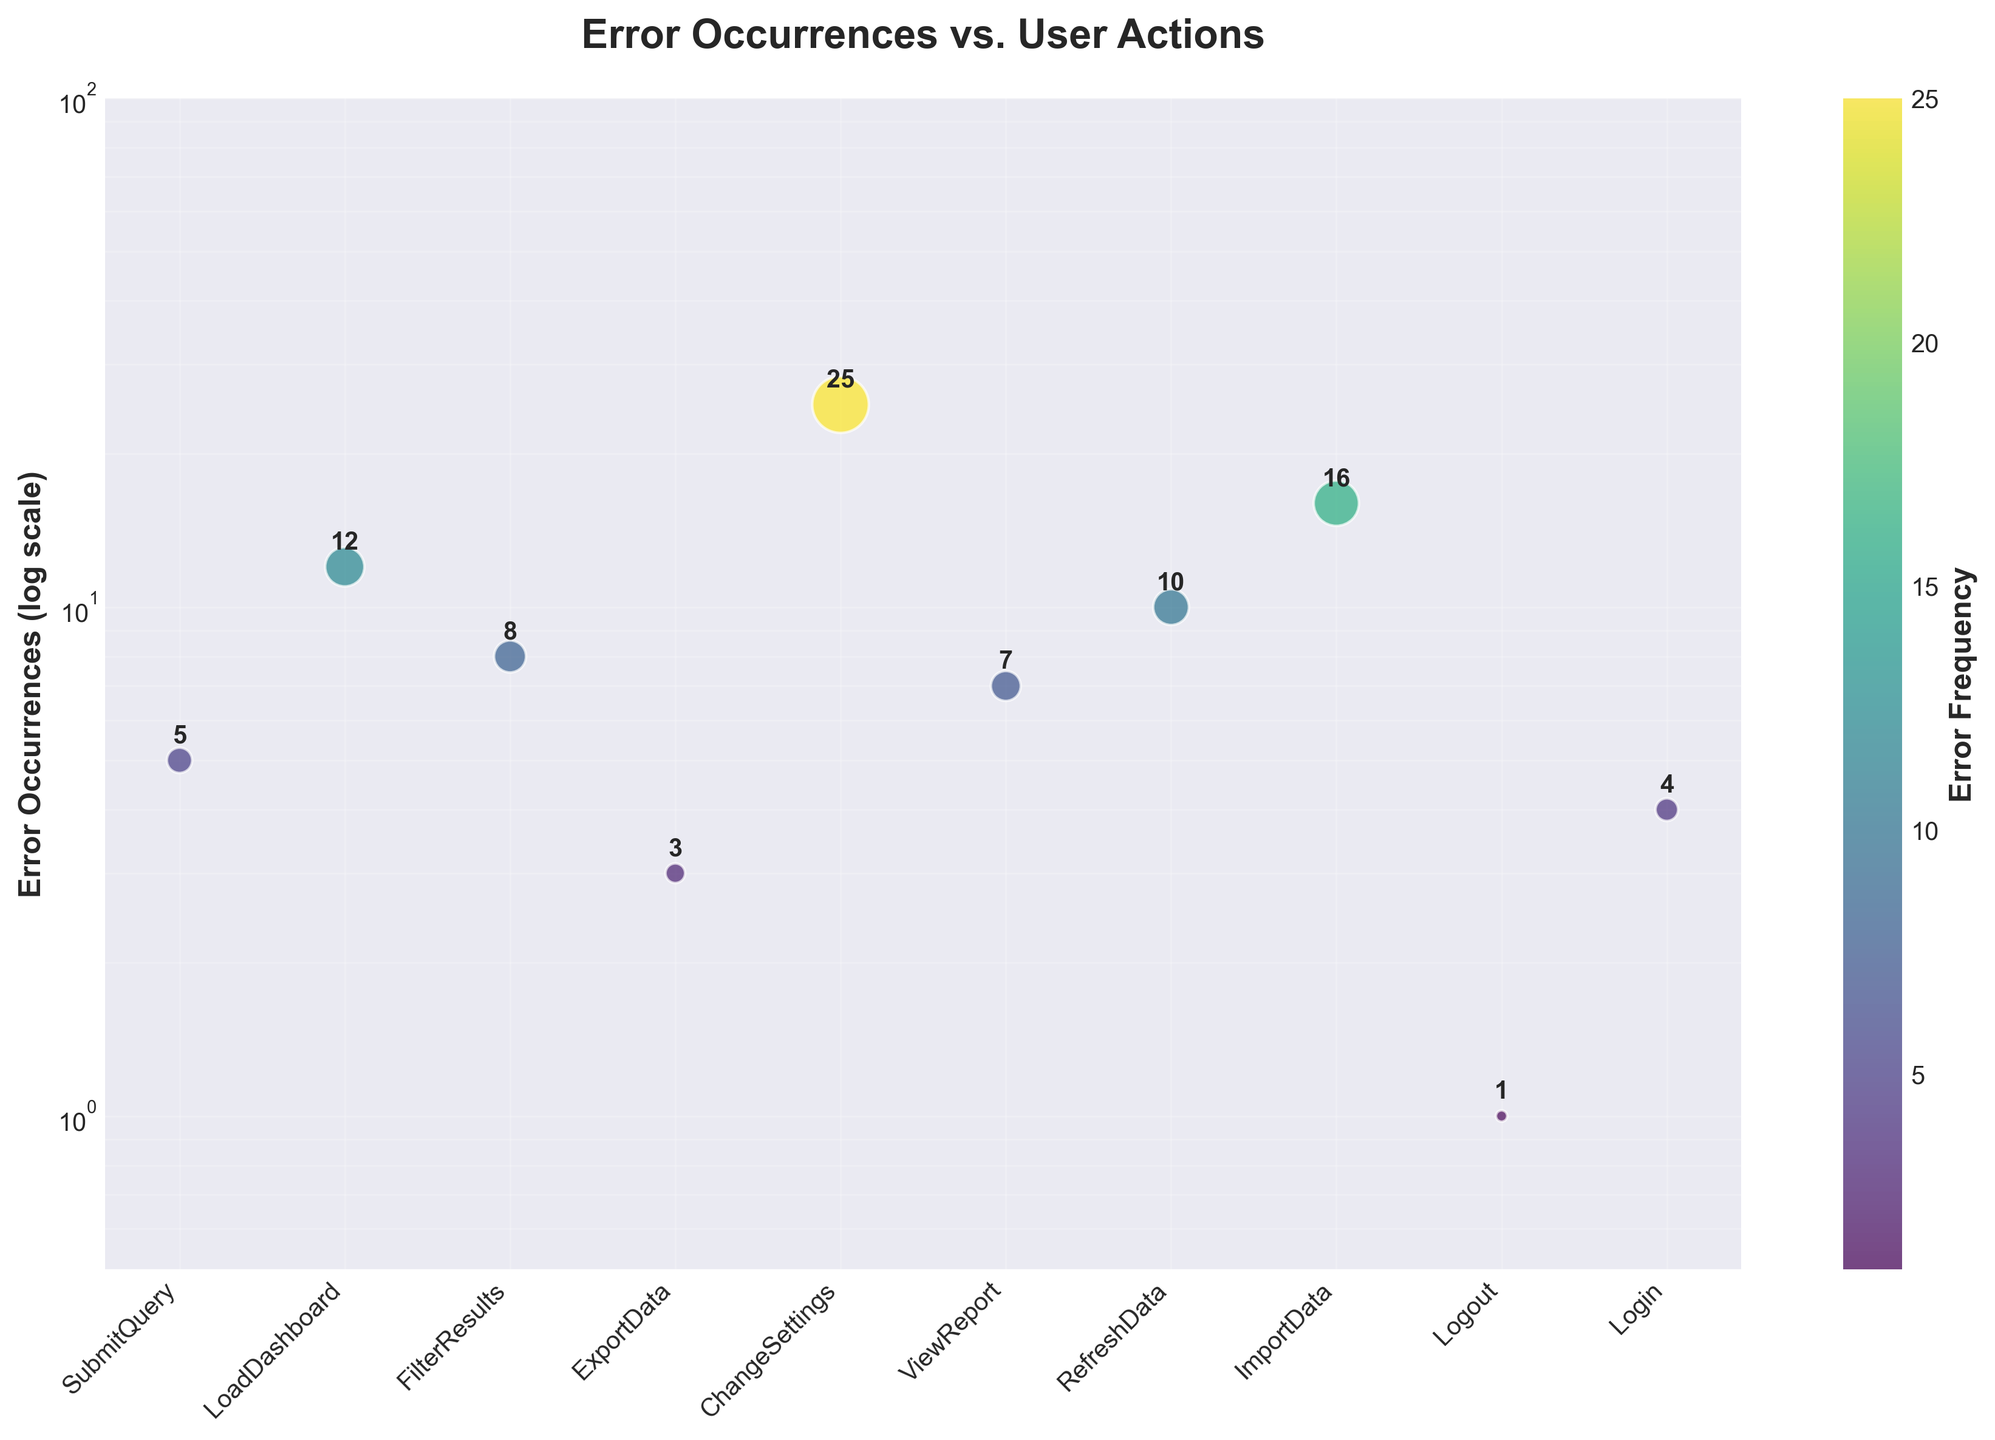What is the title of the plot? The title of the plot is found at the top of the figure and it describes what the plot is about. In this case, it reads "Error Occurrences vs. User Actions."
Answer: Error Occurrences vs. User Actions What axis is set to a log scale? This can be observed by noting the y-axis labels, which show logarithmic increments (e.g., 1, 10, 100). This indicates that the y-axis uses a log scale.
Answer: The y-axis How many user actions are displayed in the scatter plot? You can count the number of distinct labels on the x-axis or the individual data points in the plot. Each label corresponds to one action.
Answer: 10 Which user action has the most error occurrences? By identifying the point with the highest y-value, you can find the user action associated with the most errors. The label beneath this point on the x-axis is "ChangeSettings" with 25 errors.
Answer: ChangeSettings What is the range of error occurrences shown in the plot? To determine the range, find the difference between the smallest and largest y-values on the log scale. The smallest is 1 (Logout) and the largest is 25 (ChangeSettings), giving a range of 1 to 25.
Answer: 1 to 25 Which user action has the fewest error occurrences? Look for the data point with the lowest y-value. In this case, the lowest value is 1, corresponding to the "Logout" action.
Answer: Logout How many user actions have error occurrences in the range of 1 to 10? Count the number of data points with y-values between 1 and 10. These are: SubmitQuery (5), ExportData (3), ViewReport (7), Logout (1), and Login (4). Therefore, there are 5 actions.
Answer: 5 Which user action has more error occurrences: RefreshData or ImportData? Compare the y-values of the points associated with "RefreshData" (10) and "ImportData" (16). ImportData has a higher y-value.
Answer: ImportData What color corresponds to higher error occurrences on the scatter plot? Observing the color gradient in the scatter plot, higher error occurrences are represented by lighter shades in the viridis color map.
Answer: Lighter shades Is there a significant difference in error occurrences between LoadDashboard and FilterResults? Compare the y-values for these actions. LoadDashboard has 12 error occurrences and FilterResults has 8. The difference is 4, which may not be considered significant depending on the context.
Answer: No significant difference 